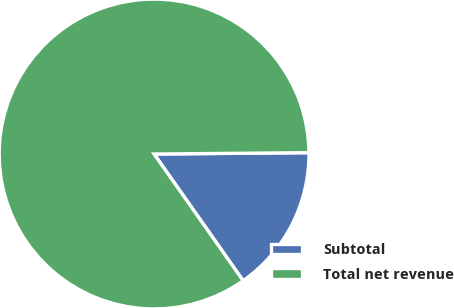<chart> <loc_0><loc_0><loc_500><loc_500><pie_chart><fcel>Subtotal<fcel>Total net revenue<nl><fcel>15.39%<fcel>84.61%<nl></chart> 